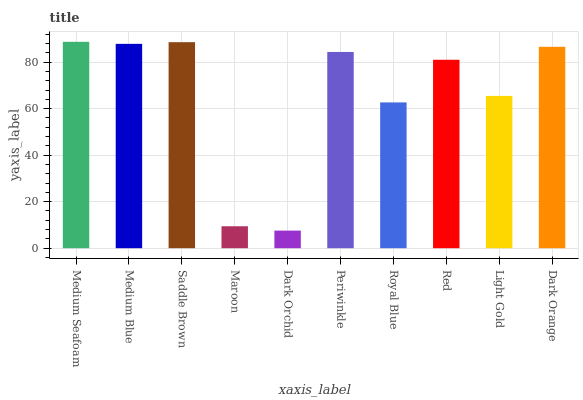Is Medium Blue the minimum?
Answer yes or no. No. Is Medium Blue the maximum?
Answer yes or no. No. Is Medium Seafoam greater than Medium Blue?
Answer yes or no. Yes. Is Medium Blue less than Medium Seafoam?
Answer yes or no. Yes. Is Medium Blue greater than Medium Seafoam?
Answer yes or no. No. Is Medium Seafoam less than Medium Blue?
Answer yes or no. No. Is Periwinkle the high median?
Answer yes or no. Yes. Is Red the low median?
Answer yes or no. Yes. Is Maroon the high median?
Answer yes or no. No. Is Light Gold the low median?
Answer yes or no. No. 